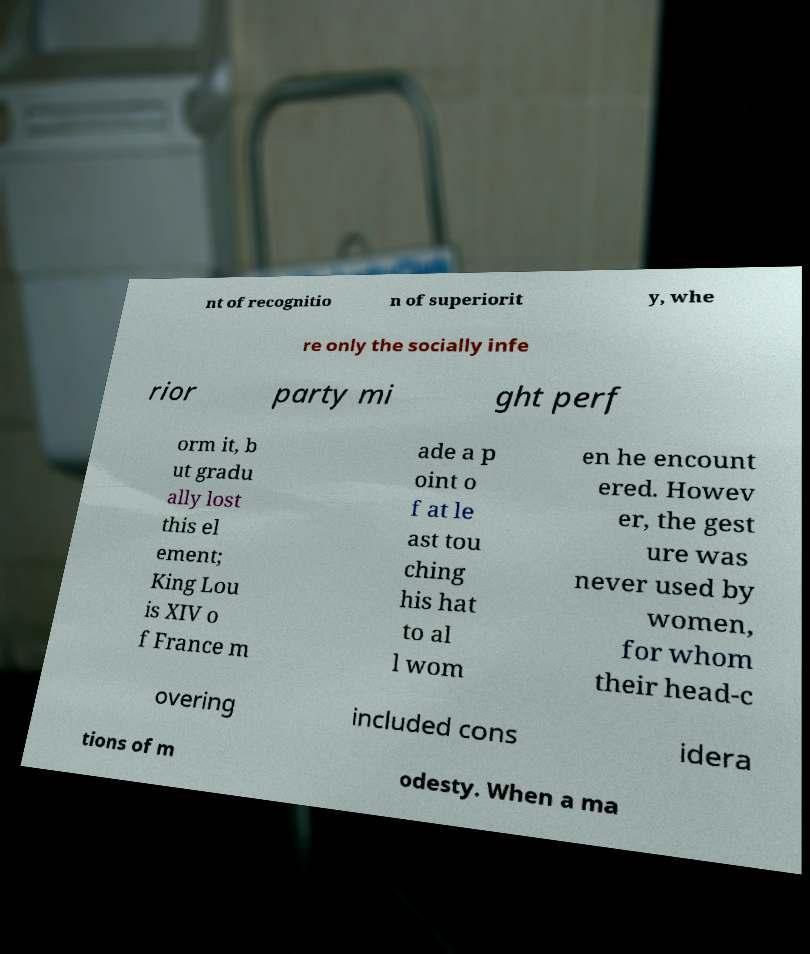Could you assist in decoding the text presented in this image and type it out clearly? nt of recognitio n of superiorit y, whe re only the socially infe rior party mi ght perf orm it, b ut gradu ally lost this el ement; King Lou is XIV o f France m ade a p oint o f at le ast tou ching his hat to al l wom en he encount ered. Howev er, the gest ure was never used by women, for whom their head-c overing included cons idera tions of m odesty. When a ma 